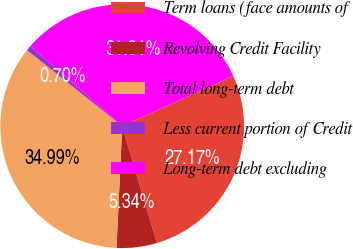<chart> <loc_0><loc_0><loc_500><loc_500><pie_chart><fcel>Term loans (face amounts of<fcel>Revolving Credit Facility<fcel>Total long-term debt<fcel>Less current portion of Credit<fcel>Long-term debt excluding<nl><fcel>27.17%<fcel>5.34%<fcel>34.99%<fcel>0.7%<fcel>31.81%<nl></chart> 